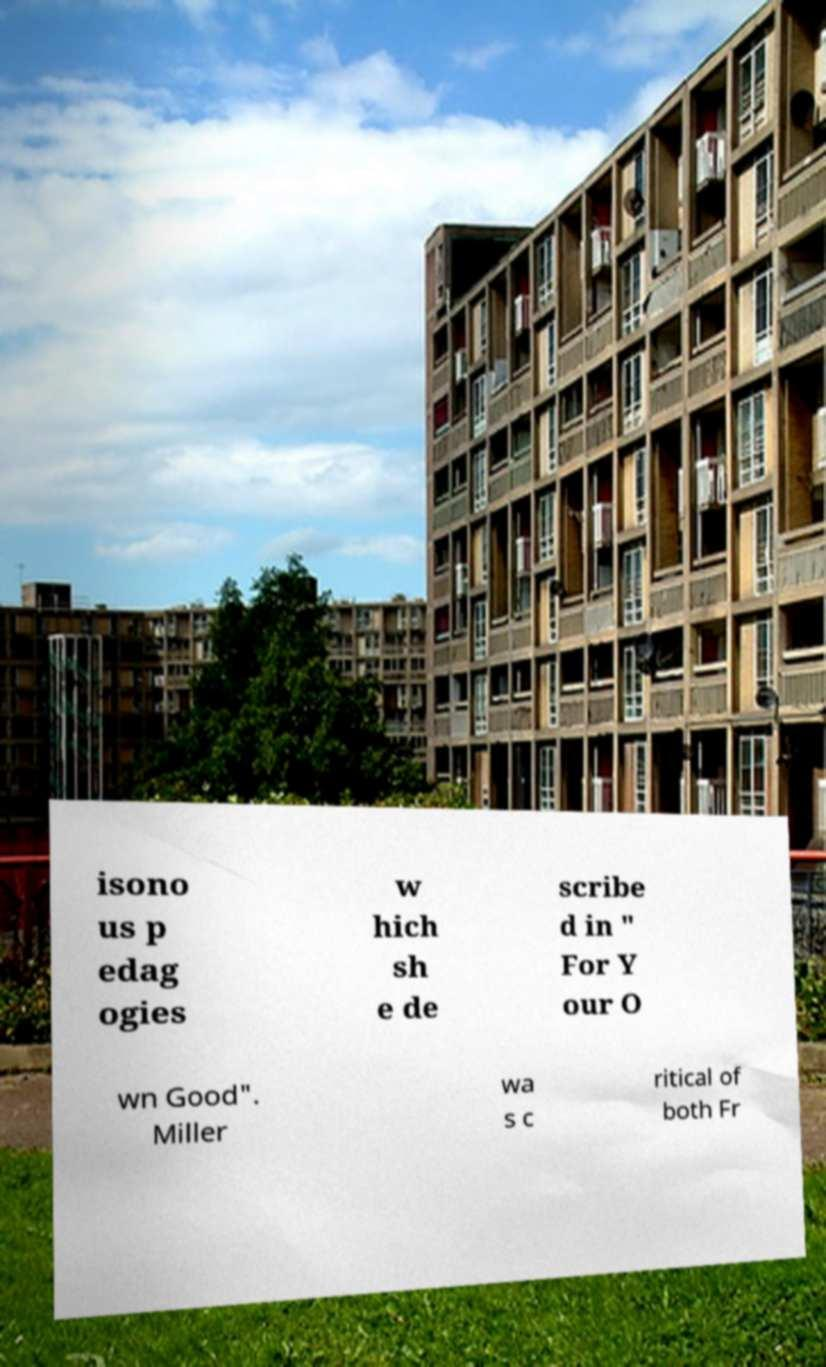Could you assist in decoding the text presented in this image and type it out clearly? isono us p edag ogies w hich sh e de scribe d in " For Y our O wn Good". Miller wa s c ritical of both Fr 